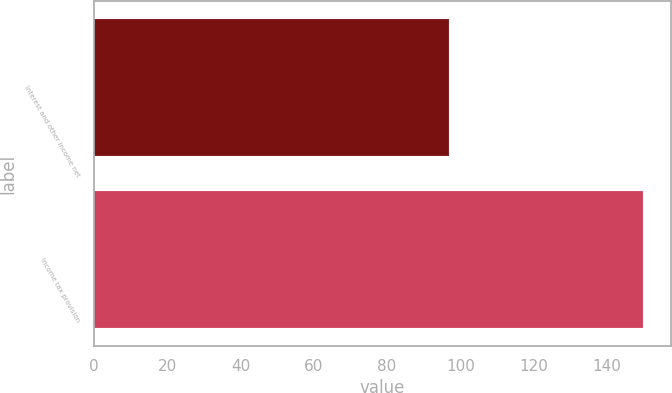<chart> <loc_0><loc_0><loc_500><loc_500><bar_chart><fcel>Interest and other income net<fcel>Income tax provision<nl><fcel>96.8<fcel>149.8<nl></chart> 